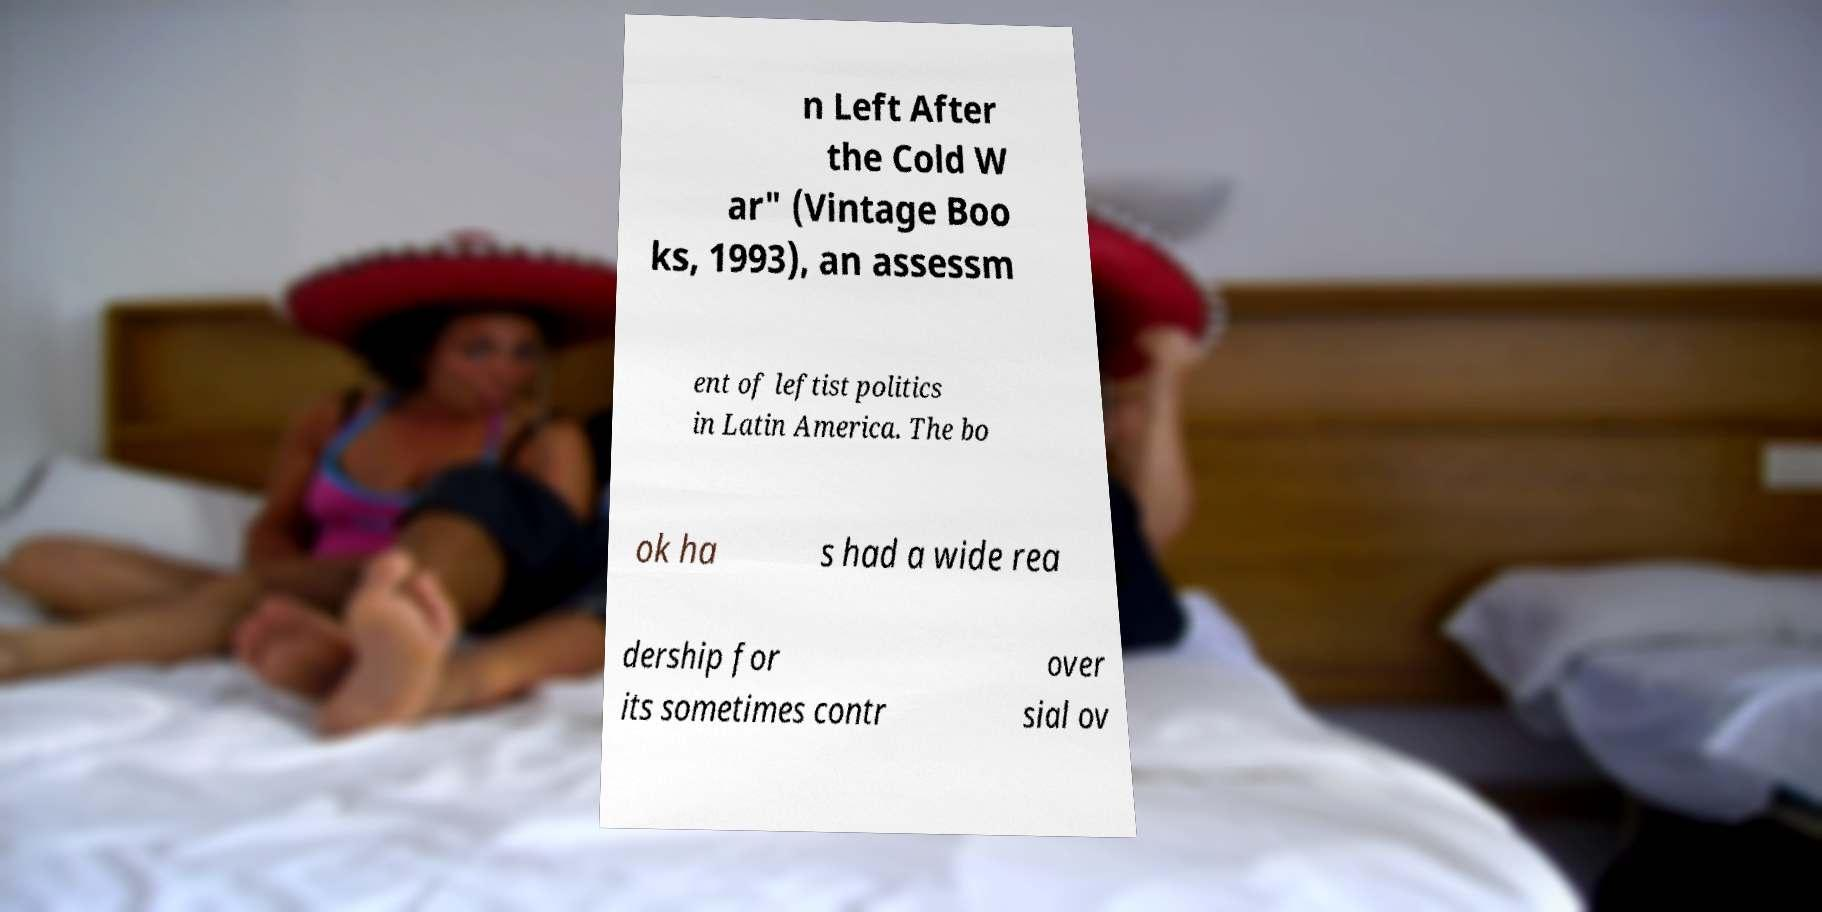Could you assist in decoding the text presented in this image and type it out clearly? n Left After the Cold W ar" (Vintage Boo ks, 1993), an assessm ent of leftist politics in Latin America. The bo ok ha s had a wide rea dership for its sometimes contr over sial ov 